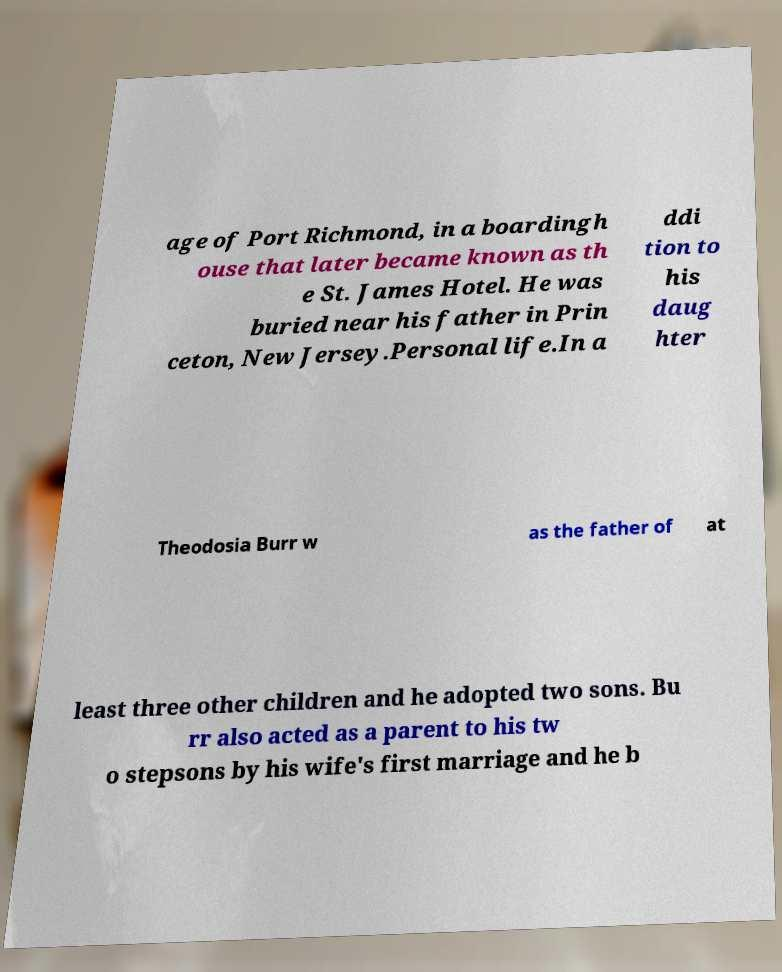I need the written content from this picture converted into text. Can you do that? age of Port Richmond, in a boardingh ouse that later became known as th e St. James Hotel. He was buried near his father in Prin ceton, New Jersey.Personal life.In a ddi tion to his daug hter Theodosia Burr w as the father of at least three other children and he adopted two sons. Bu rr also acted as a parent to his tw o stepsons by his wife's first marriage and he b 